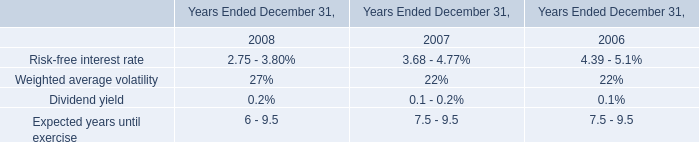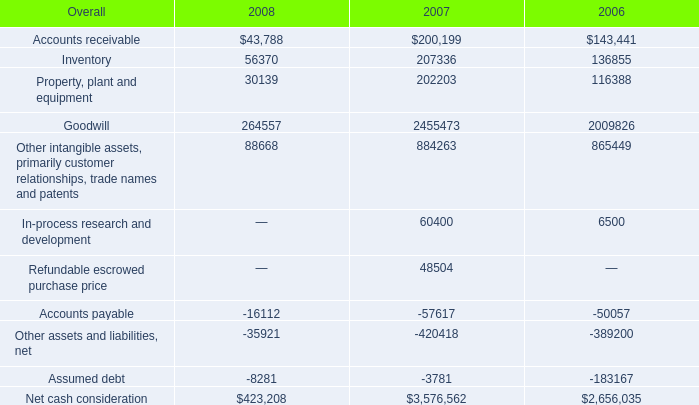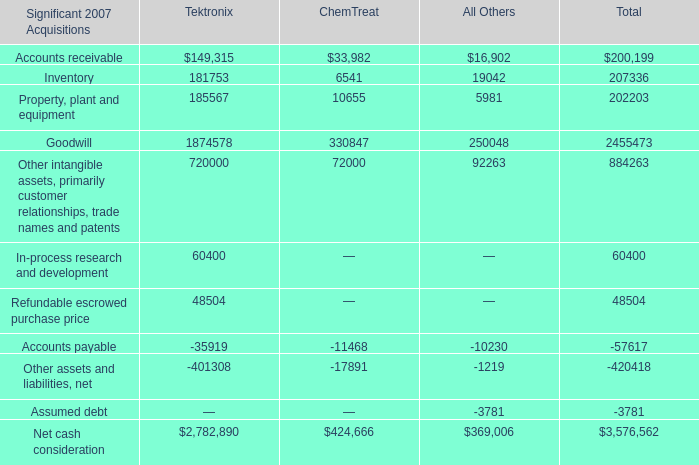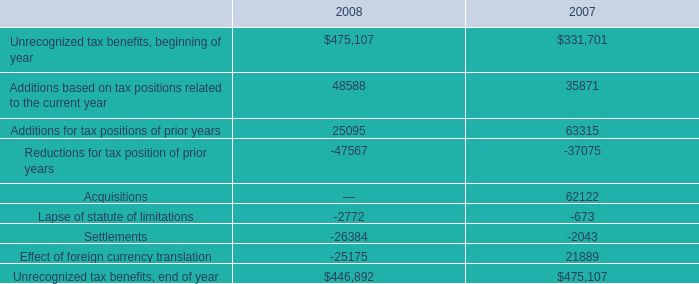What is the average amount of Unrecognized tax benefits, end of year of 2008, and Refundable escrowed purchase price of Tektronix ? 
Computations: ((446892.0 + 48504.0) / 2)
Answer: 247698.0. 